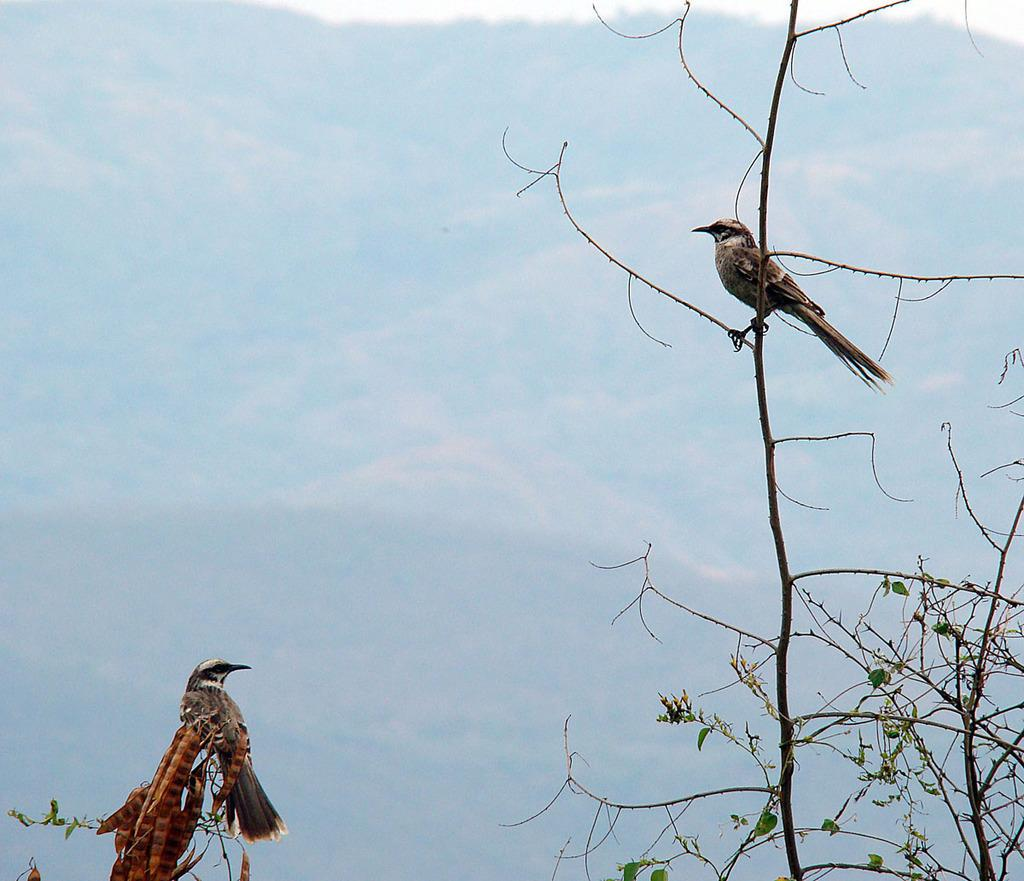What type of animals can be seen in the image? There are birds in the image. What is the condition of the trees where the birds are perched? The trees are dry in the image. What color are the leaves visible in the image? There are green leaves in the image. What colors can be observed on the birds? The birds have brown, black, and cream colors. What can be seen in the distance in the image? There are mountains visible in the background of the image. What type of sock is the rat wearing in the image? There is no rat or sock present in the image; it features birds on dry trees with green leaves and mountains in the background. 